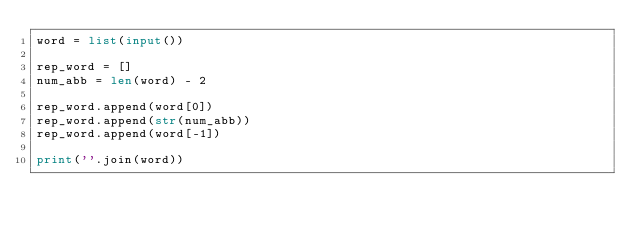Convert code to text. <code><loc_0><loc_0><loc_500><loc_500><_Python_>word = list(input())

rep_word = []
num_abb = len(word) - 2

rep_word.append(word[0])
rep_word.append(str(num_abb))
rep_word.append(word[-1])

print(''.join(word))</code> 